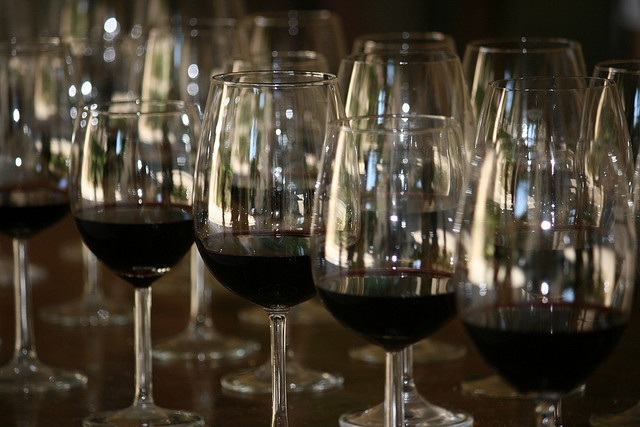Describe the objects in this image and their specific colors. I can see wine glass in black and gray tones, wine glass in black and gray tones, wine glass in black and gray tones, wine glass in black, gray, and darkgreen tones, and wine glass in black and gray tones in this image. 